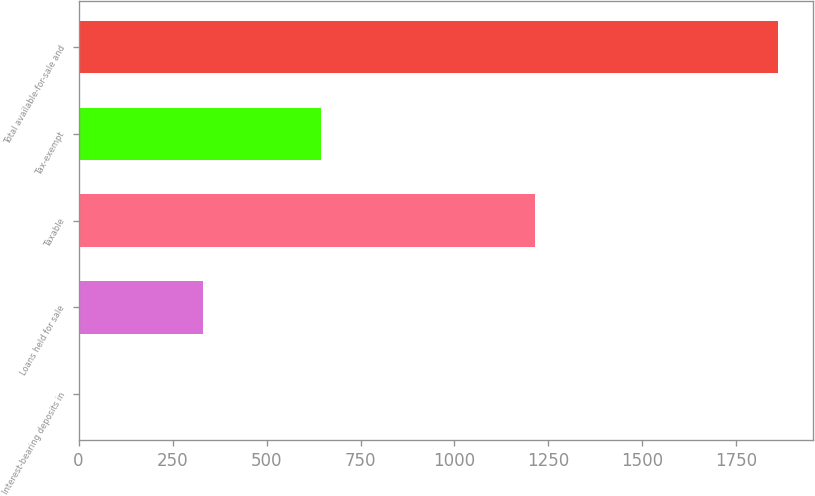Convert chart. <chart><loc_0><loc_0><loc_500><loc_500><bar_chart><fcel>Interest-bearing deposits in<fcel>Loans held for sale<fcel>Taxable<fcel>Tax-exempt<fcel>Total available-for-sale and<nl><fcel>5<fcel>331<fcel>1214<fcel>646<fcel>1860<nl></chart> 